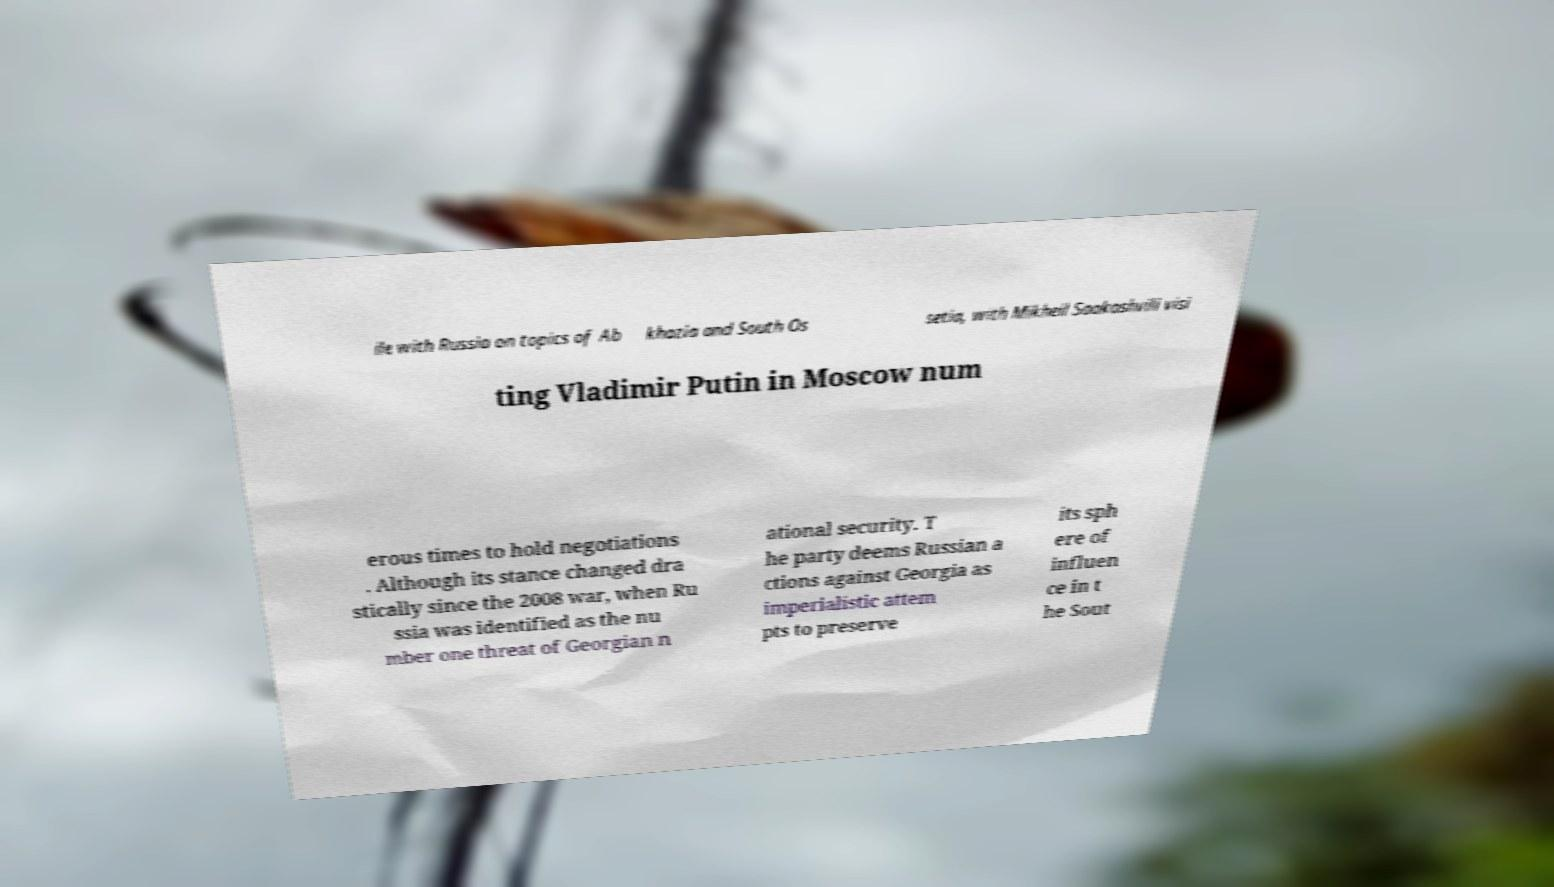What messages or text are displayed in this image? I need them in a readable, typed format. ile with Russia on topics of Ab khazia and South Os setia, with Mikheil Saakashvili visi ting Vladimir Putin in Moscow num erous times to hold negotiations . Although its stance changed dra stically since the 2008 war, when Ru ssia was identified as the nu mber one threat of Georgian n ational security. T he party deems Russian a ctions against Georgia as imperialistic attem pts to preserve its sph ere of influen ce in t he Sout 